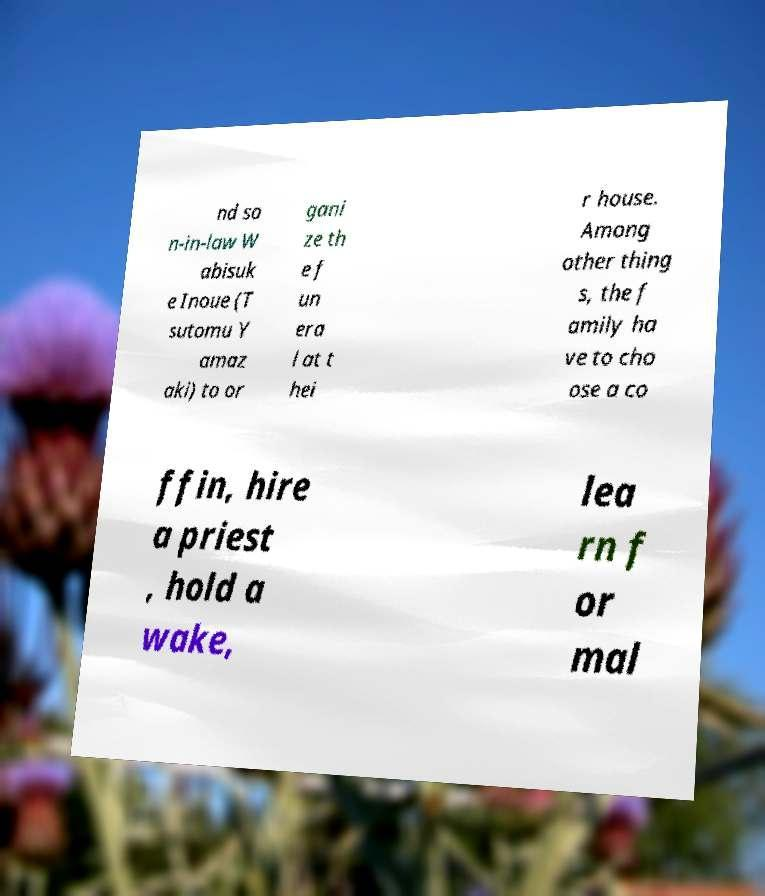There's text embedded in this image that I need extracted. Can you transcribe it verbatim? nd so n-in-law W abisuk e Inoue (T sutomu Y amaz aki) to or gani ze th e f un era l at t hei r house. Among other thing s, the f amily ha ve to cho ose a co ffin, hire a priest , hold a wake, lea rn f or mal 